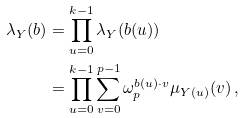Convert formula to latex. <formula><loc_0><loc_0><loc_500><loc_500>\lambda _ { Y } ( b ) & = \prod _ { u = 0 } ^ { k - 1 } \lambda _ { Y } ( b ( u ) ) \\ & = \prod _ { u = 0 } ^ { k - 1 } \sum _ { v = 0 } ^ { p - 1 } \omega _ { p } ^ { b ( u ) \cdot v } \mu _ { Y ( u ) } ( v ) \, ,</formula> 